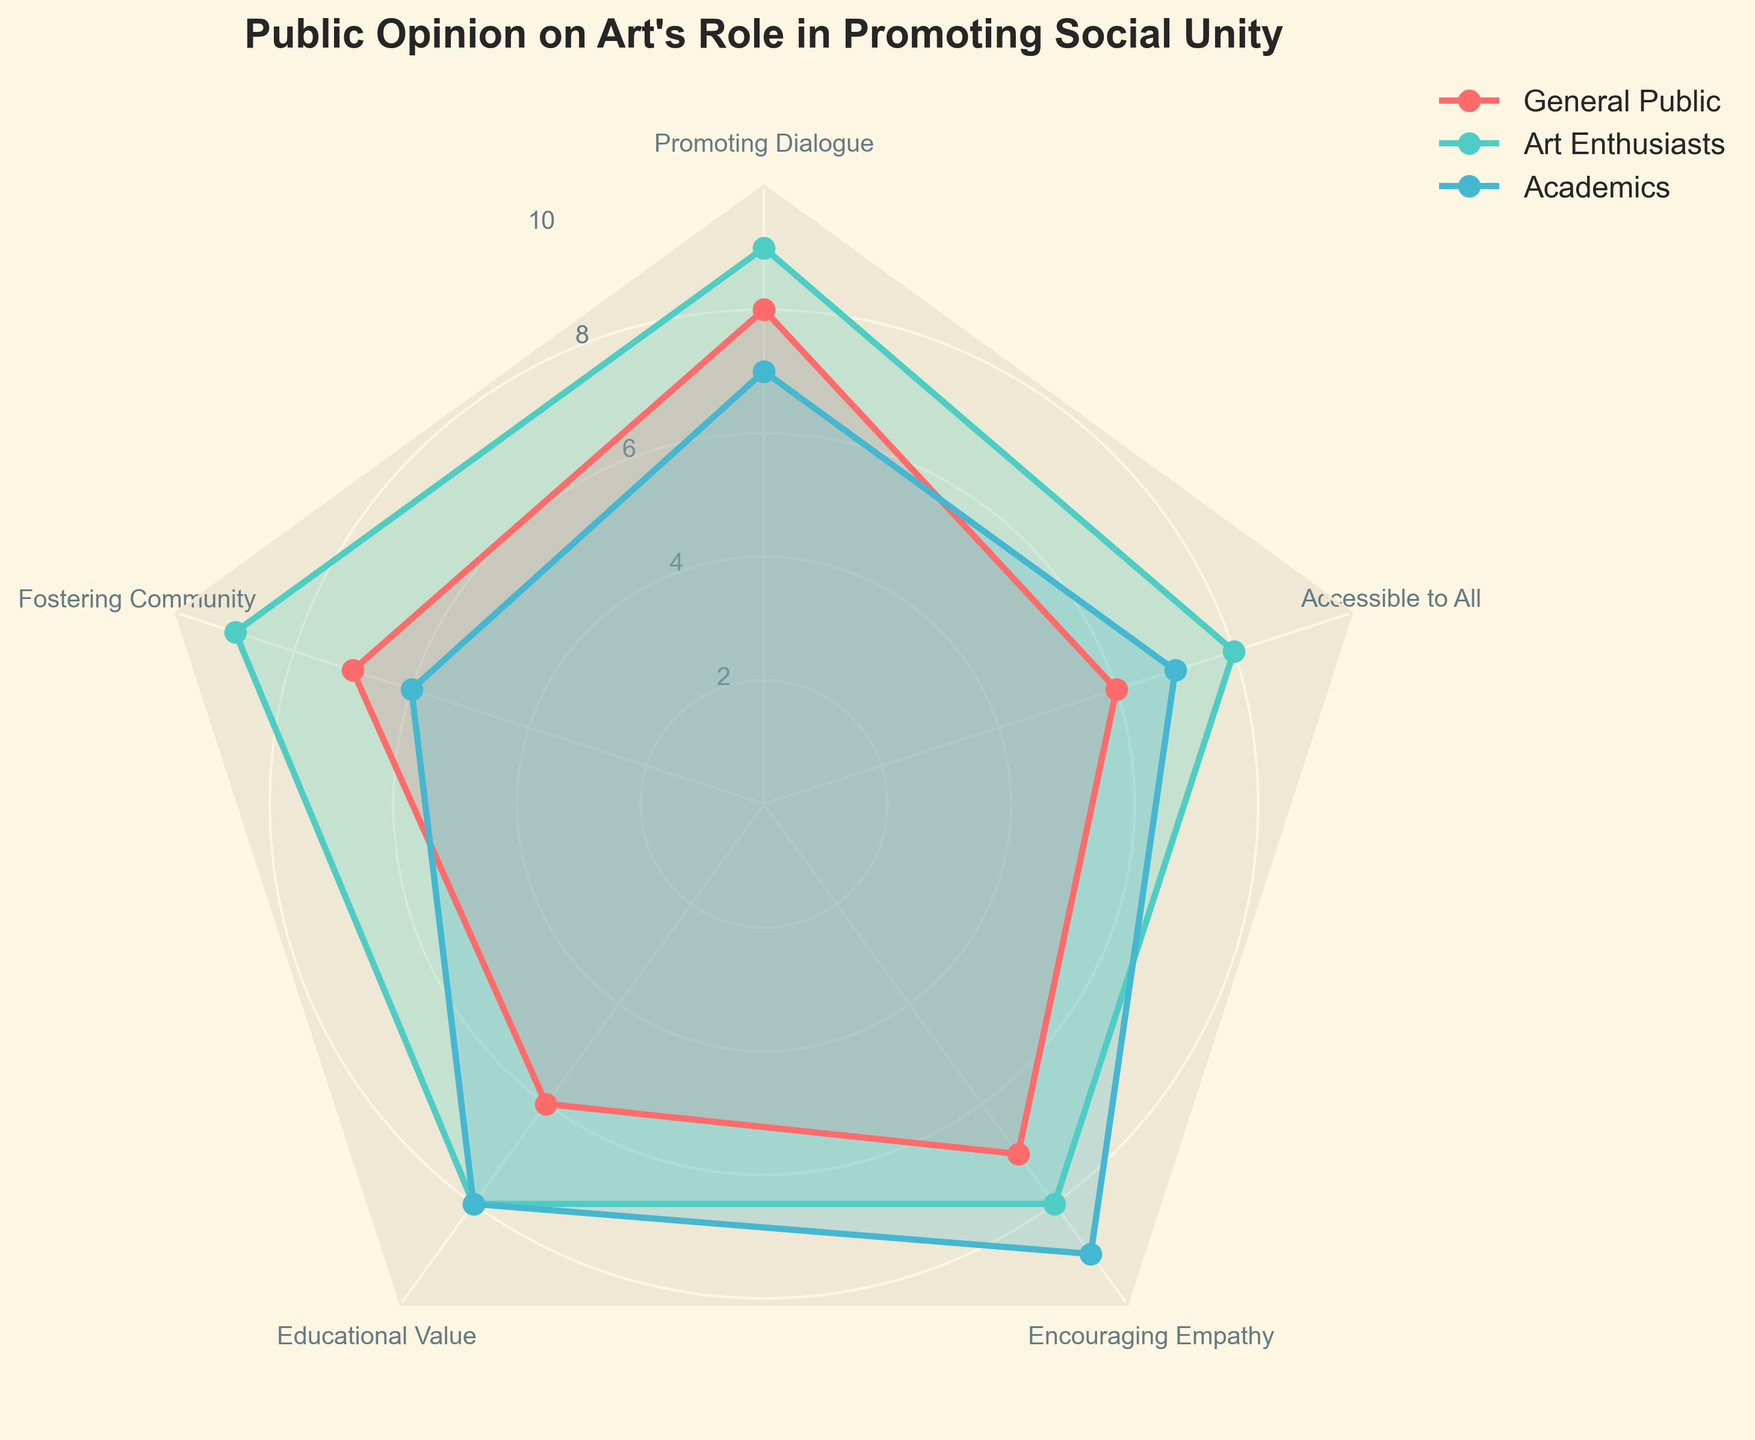What is the title of the figure? The title is prominently displayed at the top of the chart. It reads "Public Opinion on Art's Role in Promoting Social Unity."
Answer: Public Opinion on Art's Role in Promoting Social Unity Which group values "Promoting Dialogue" the most? By examining the segment labeled "Promoting Dialogue," we see that Art Enthusiasts have the highest value at 9.
Answer: Art Enthusiasts How many categories are displayed in the radar chart? Count the number of axes or spokes extending from the center of the radar chart. There are 5 categories.
Answer: 5 Which category do Academics value more than the General Public? By comparing the values of each category for Academics and the General Public, we see that Academics rate "Educational Value" and "Encouraging Empathy" higher than the General Public.
Answer: Educational Value and Encouraging Empathy What is the average value for Art Enthusiasts? Art Enthusiasts have values of 9, 9, 8, 8, and 8. Adding these gives 9 + 9 + 8 + 8 + 8 = 42. Dividing by 5 yields an average of 42/5 = 8.4.
Answer: 8.4 Which group has the most balanced values across all categories? Compare the variability in the values for each group. The General Public and Academics display more variability, while Art Enthusiasts have values that are mostly 8 or 9. Thus, Art Enthusiasts are the most balanced.
Answer: Art Enthusiasts Which category shows the greatest difference between the highest and lowest values? Compare the range of each category. "Promoting Dialogue" has values of 8, 9, and 7, giving a difference of 9 - 7 = 2. "Fostering Community" ranges from 6 to 9 (difference of 3), "Educational Value" has a range of 2, "Encouraging Empathy" has 2, and "Accessible to All" has 8 - 6 = 2. The greatest difference is in "Fostering Community," with a difference of 3.
Answer: Fostering Community Which group rates "Accessible to All" higher than the other groups? Compare the values for "Accessible to All." Art Enthusiasts have the highest value at 8.
Answer: Art Enthusiasts Are the values for "Encouraging Empathy" higher or lower compared to "Fostering Community" for Academics? Comparing the values, "Encouraging Empathy" is rated 9 and "Fostering Community" is rated 6 by Academics. So, "Encouraging Empathy" is higher.
Answer: Higher What is the sum of the values for "Accessible to All" across all groups? Sum the values for "Accessible to All" for each group. General Public: 6, Art Enthusiasts: 8, Academics: 7. Total = 6 + 8 + 7 = 21.
Answer: 21 